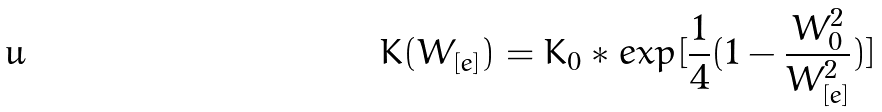Convert formula to latex. <formula><loc_0><loc_0><loc_500><loc_500>K ( W _ { [ e ] } ) = K _ { 0 } * e x p [ \frac { 1 } { 4 } ( 1 - \frac { W _ { 0 } ^ { 2 } } { W _ { [ e ] } ^ { 2 } } ) ]</formula> 